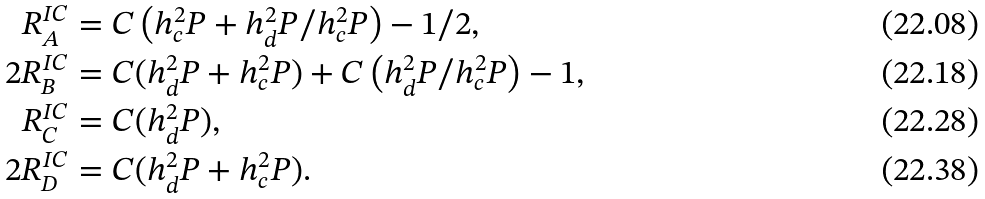Convert formula to latex. <formula><loc_0><loc_0><loc_500><loc_500>R ^ { I C } _ { A } & = C \left ( h _ { c } ^ { 2 } P + { h _ { d } ^ { 2 } P } / { h _ { c } ^ { 2 } P } \right ) - 1 / 2 , \\ 2 R ^ { I C } _ { B } & = C ( h _ { d } ^ { 2 } P + h _ { c } ^ { 2 } P ) + C \left ( { h _ { d } ^ { 2 } P } / { h _ { c } ^ { 2 } P } \right ) - 1 , \\ R ^ { I C } _ { C } & = C ( h _ { d } ^ { 2 } P ) , \\ 2 R ^ { I C } _ { D } & = C ( h _ { d } ^ { 2 } P + h _ { c } ^ { 2 } P ) .</formula> 